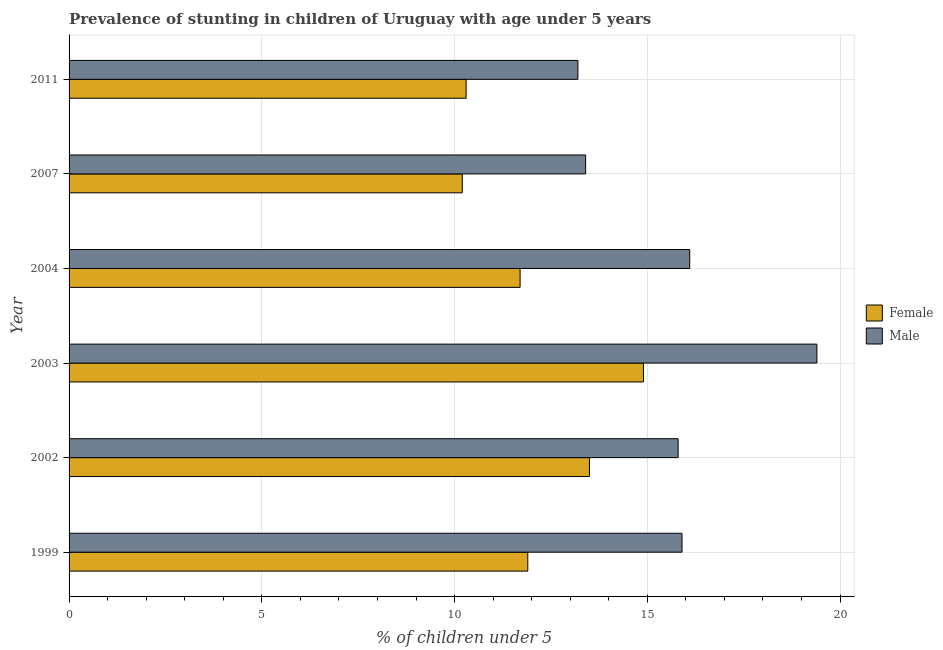What is the label of the 6th group of bars from the top?
Keep it short and to the point. 1999. What is the percentage of stunted female children in 2011?
Ensure brevity in your answer.  10.3. Across all years, what is the maximum percentage of stunted female children?
Make the answer very short. 14.9. Across all years, what is the minimum percentage of stunted male children?
Keep it short and to the point. 13.2. What is the total percentage of stunted female children in the graph?
Make the answer very short. 72.5. What is the difference between the percentage of stunted female children in 1999 and that in 2004?
Provide a succinct answer. 0.2. What is the difference between the percentage of stunted female children in 1999 and the percentage of stunted male children in 2007?
Make the answer very short. -1.5. What is the average percentage of stunted female children per year?
Your answer should be very brief. 12.08. In the year 1999, what is the difference between the percentage of stunted male children and percentage of stunted female children?
Offer a very short reply. 4. In how many years, is the percentage of stunted male children greater than 19 %?
Keep it short and to the point. 1. Is the percentage of stunted female children in 2002 less than that in 2007?
Offer a terse response. No. Is the difference between the percentage of stunted male children in 2002 and 2007 greater than the difference between the percentage of stunted female children in 2002 and 2007?
Offer a very short reply. No. Is the sum of the percentage of stunted female children in 2003 and 2004 greater than the maximum percentage of stunted male children across all years?
Your answer should be very brief. Yes. What does the 2nd bar from the top in 1999 represents?
Provide a short and direct response. Female. How many bars are there?
Give a very brief answer. 12. Are the values on the major ticks of X-axis written in scientific E-notation?
Your answer should be very brief. No. Does the graph contain any zero values?
Provide a succinct answer. No. How many legend labels are there?
Give a very brief answer. 2. How are the legend labels stacked?
Your answer should be compact. Vertical. What is the title of the graph?
Give a very brief answer. Prevalence of stunting in children of Uruguay with age under 5 years. What is the label or title of the X-axis?
Offer a very short reply.  % of children under 5. What is the label or title of the Y-axis?
Provide a short and direct response. Year. What is the  % of children under 5 of Female in 1999?
Offer a very short reply. 11.9. What is the  % of children under 5 of Male in 1999?
Keep it short and to the point. 15.9. What is the  % of children under 5 of Male in 2002?
Offer a very short reply. 15.8. What is the  % of children under 5 of Female in 2003?
Your answer should be very brief. 14.9. What is the  % of children under 5 of Male in 2003?
Your answer should be compact. 19.4. What is the  % of children under 5 of Female in 2004?
Ensure brevity in your answer.  11.7. What is the  % of children under 5 of Male in 2004?
Provide a short and direct response. 16.1. What is the  % of children under 5 in Female in 2007?
Your answer should be compact. 10.2. What is the  % of children under 5 in Male in 2007?
Ensure brevity in your answer.  13.4. What is the  % of children under 5 of Female in 2011?
Your answer should be very brief. 10.3. What is the  % of children under 5 of Male in 2011?
Offer a terse response. 13.2. Across all years, what is the maximum  % of children under 5 in Female?
Provide a short and direct response. 14.9. Across all years, what is the maximum  % of children under 5 in Male?
Give a very brief answer. 19.4. Across all years, what is the minimum  % of children under 5 in Female?
Provide a short and direct response. 10.2. Across all years, what is the minimum  % of children under 5 in Male?
Offer a terse response. 13.2. What is the total  % of children under 5 of Female in the graph?
Give a very brief answer. 72.5. What is the total  % of children under 5 of Male in the graph?
Offer a terse response. 93.8. What is the difference between the  % of children under 5 in Female in 1999 and that in 2002?
Keep it short and to the point. -1.6. What is the difference between the  % of children under 5 of Female in 1999 and that in 2003?
Give a very brief answer. -3. What is the difference between the  % of children under 5 of Female in 1999 and that in 2004?
Offer a very short reply. 0.2. What is the difference between the  % of children under 5 of Male in 1999 and that in 2007?
Offer a very short reply. 2.5. What is the difference between the  % of children under 5 of Female in 1999 and that in 2011?
Provide a short and direct response. 1.6. What is the difference between the  % of children under 5 of Male in 1999 and that in 2011?
Ensure brevity in your answer.  2.7. What is the difference between the  % of children under 5 of Male in 2002 and that in 2003?
Your response must be concise. -3.6. What is the difference between the  % of children under 5 of Female in 2002 and that in 2004?
Offer a terse response. 1.8. What is the difference between the  % of children under 5 of Female in 2002 and that in 2007?
Your answer should be very brief. 3.3. What is the difference between the  % of children under 5 of Male in 2002 and that in 2007?
Make the answer very short. 2.4. What is the difference between the  % of children under 5 of Female in 2002 and that in 2011?
Keep it short and to the point. 3.2. What is the difference between the  % of children under 5 in Female in 2003 and that in 2004?
Your response must be concise. 3.2. What is the difference between the  % of children under 5 in Female in 2003 and that in 2007?
Your answer should be very brief. 4.7. What is the difference between the  % of children under 5 of Female in 2003 and that in 2011?
Your answer should be compact. 4.6. What is the difference between the  % of children under 5 in Male in 2003 and that in 2011?
Give a very brief answer. 6.2. What is the difference between the  % of children under 5 in Female in 2004 and that in 2007?
Ensure brevity in your answer.  1.5. What is the difference between the  % of children under 5 in Male in 2004 and that in 2007?
Ensure brevity in your answer.  2.7. What is the difference between the  % of children under 5 of Female in 2004 and that in 2011?
Provide a succinct answer. 1.4. What is the difference between the  % of children under 5 of Female in 2007 and that in 2011?
Offer a very short reply. -0.1. What is the difference between the  % of children under 5 of Female in 1999 and the  % of children under 5 of Male in 2002?
Your response must be concise. -3.9. What is the difference between the  % of children under 5 of Female in 1999 and the  % of children under 5 of Male in 2003?
Your answer should be very brief. -7.5. What is the difference between the  % of children under 5 in Female in 1999 and the  % of children under 5 in Male in 2004?
Your response must be concise. -4.2. What is the difference between the  % of children under 5 of Female in 1999 and the  % of children under 5 of Male in 2007?
Offer a very short reply. -1.5. What is the difference between the  % of children under 5 in Female in 2002 and the  % of children under 5 in Male in 2007?
Your answer should be very brief. 0.1. What is the difference between the  % of children under 5 of Female in 2002 and the  % of children under 5 of Male in 2011?
Provide a short and direct response. 0.3. What is the difference between the  % of children under 5 of Female in 2003 and the  % of children under 5 of Male in 2011?
Provide a short and direct response. 1.7. What is the average  % of children under 5 in Female per year?
Your response must be concise. 12.08. What is the average  % of children under 5 of Male per year?
Your answer should be very brief. 15.63. In the year 1999, what is the difference between the  % of children under 5 in Female and  % of children under 5 in Male?
Your response must be concise. -4. In the year 2002, what is the difference between the  % of children under 5 in Female and  % of children under 5 in Male?
Your answer should be compact. -2.3. In the year 2003, what is the difference between the  % of children under 5 of Female and  % of children under 5 of Male?
Your answer should be very brief. -4.5. In the year 2004, what is the difference between the  % of children under 5 of Female and  % of children under 5 of Male?
Your response must be concise. -4.4. In the year 2011, what is the difference between the  % of children under 5 of Female and  % of children under 5 of Male?
Make the answer very short. -2.9. What is the ratio of the  % of children under 5 of Female in 1999 to that in 2002?
Give a very brief answer. 0.88. What is the ratio of the  % of children under 5 in Male in 1999 to that in 2002?
Provide a succinct answer. 1.01. What is the ratio of the  % of children under 5 of Female in 1999 to that in 2003?
Provide a succinct answer. 0.8. What is the ratio of the  % of children under 5 of Male in 1999 to that in 2003?
Provide a short and direct response. 0.82. What is the ratio of the  % of children under 5 of Female in 1999 to that in 2004?
Make the answer very short. 1.02. What is the ratio of the  % of children under 5 of Male in 1999 to that in 2004?
Your answer should be compact. 0.99. What is the ratio of the  % of children under 5 in Female in 1999 to that in 2007?
Make the answer very short. 1.17. What is the ratio of the  % of children under 5 in Male in 1999 to that in 2007?
Give a very brief answer. 1.19. What is the ratio of the  % of children under 5 in Female in 1999 to that in 2011?
Your answer should be compact. 1.16. What is the ratio of the  % of children under 5 of Male in 1999 to that in 2011?
Keep it short and to the point. 1.2. What is the ratio of the  % of children under 5 in Female in 2002 to that in 2003?
Keep it short and to the point. 0.91. What is the ratio of the  % of children under 5 of Male in 2002 to that in 2003?
Offer a very short reply. 0.81. What is the ratio of the  % of children under 5 in Female in 2002 to that in 2004?
Provide a succinct answer. 1.15. What is the ratio of the  % of children under 5 of Male in 2002 to that in 2004?
Make the answer very short. 0.98. What is the ratio of the  % of children under 5 in Female in 2002 to that in 2007?
Offer a very short reply. 1.32. What is the ratio of the  % of children under 5 of Male in 2002 to that in 2007?
Keep it short and to the point. 1.18. What is the ratio of the  % of children under 5 in Female in 2002 to that in 2011?
Offer a terse response. 1.31. What is the ratio of the  % of children under 5 of Male in 2002 to that in 2011?
Offer a terse response. 1.2. What is the ratio of the  % of children under 5 in Female in 2003 to that in 2004?
Your answer should be compact. 1.27. What is the ratio of the  % of children under 5 in Male in 2003 to that in 2004?
Your answer should be compact. 1.21. What is the ratio of the  % of children under 5 in Female in 2003 to that in 2007?
Keep it short and to the point. 1.46. What is the ratio of the  % of children under 5 of Male in 2003 to that in 2007?
Provide a succinct answer. 1.45. What is the ratio of the  % of children under 5 in Female in 2003 to that in 2011?
Offer a terse response. 1.45. What is the ratio of the  % of children under 5 in Male in 2003 to that in 2011?
Provide a succinct answer. 1.47. What is the ratio of the  % of children under 5 in Female in 2004 to that in 2007?
Provide a succinct answer. 1.15. What is the ratio of the  % of children under 5 of Male in 2004 to that in 2007?
Ensure brevity in your answer.  1.2. What is the ratio of the  % of children under 5 of Female in 2004 to that in 2011?
Provide a succinct answer. 1.14. What is the ratio of the  % of children under 5 of Male in 2004 to that in 2011?
Ensure brevity in your answer.  1.22. What is the ratio of the  % of children under 5 of Female in 2007 to that in 2011?
Provide a succinct answer. 0.99. What is the ratio of the  % of children under 5 in Male in 2007 to that in 2011?
Offer a terse response. 1.02. What is the difference between the highest and the second highest  % of children under 5 of Male?
Your response must be concise. 3.3. What is the difference between the highest and the lowest  % of children under 5 of Female?
Make the answer very short. 4.7. What is the difference between the highest and the lowest  % of children under 5 in Male?
Your response must be concise. 6.2. 